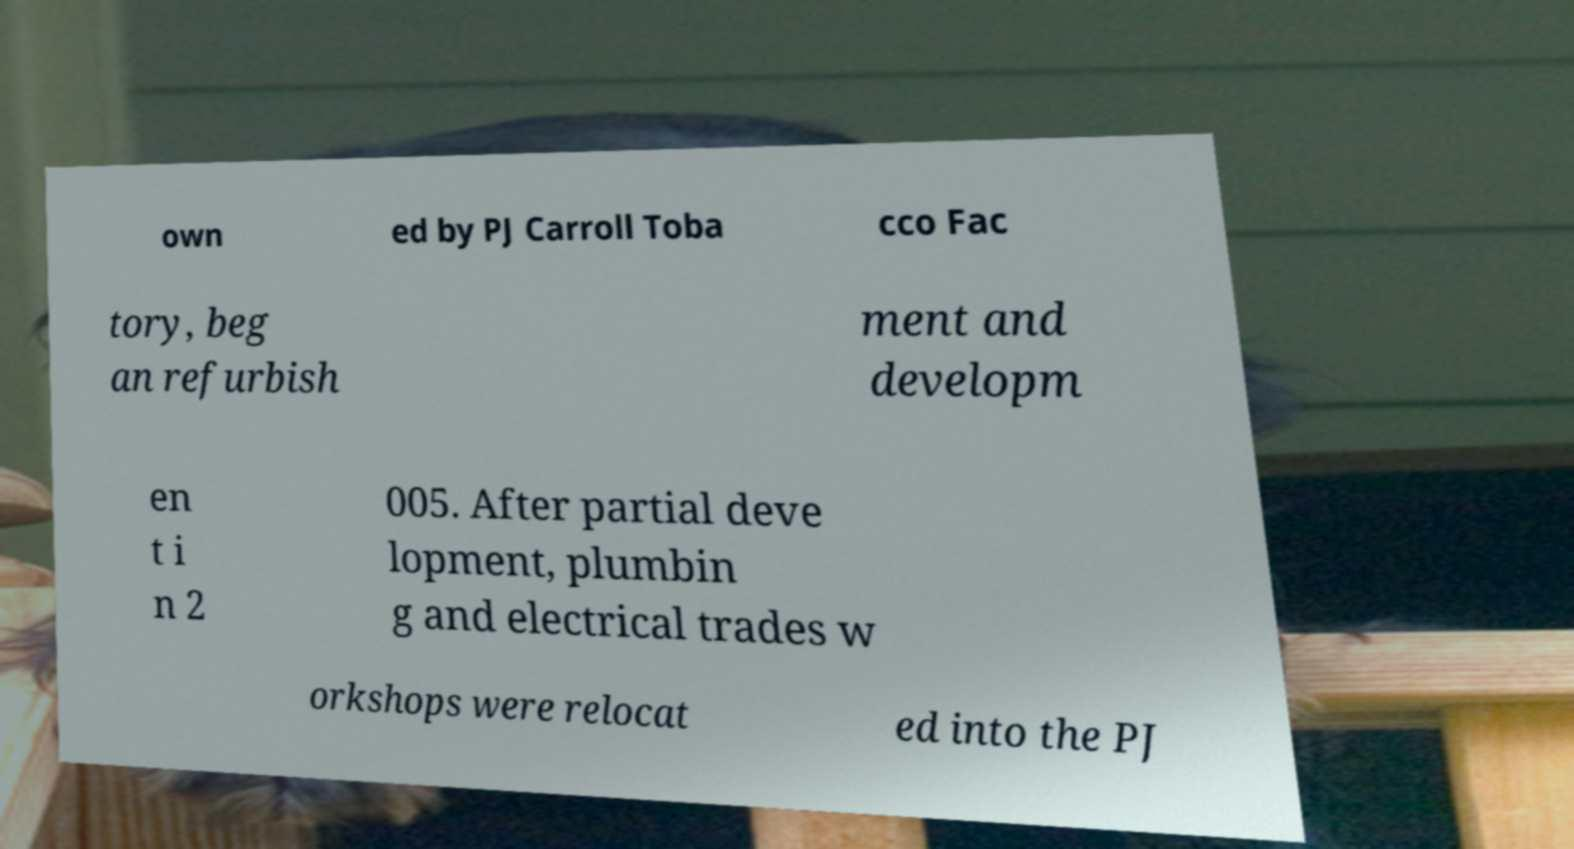Could you extract and type out the text from this image? own ed by PJ Carroll Toba cco Fac tory, beg an refurbish ment and developm en t i n 2 005. After partial deve lopment, plumbin g and electrical trades w orkshops were relocat ed into the PJ 